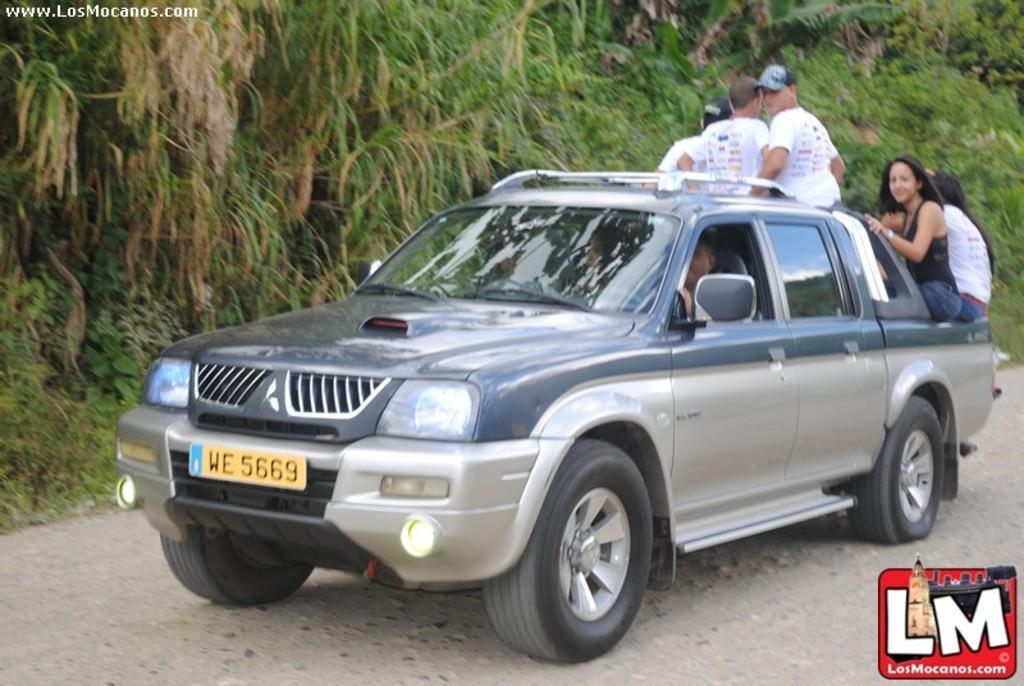Can you describe this image briefly? there is a vehicle. in the front 2 people are sitting. at the back 3 people are standing wearing white t shirts and 2 people are sitting wearing black and white t shirt respectively. the vehicle is on the road. at the left there are trees. 